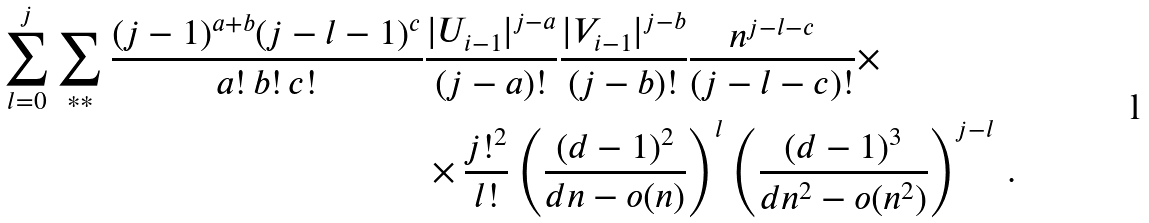<formula> <loc_0><loc_0><loc_500><loc_500>\sum _ { l = 0 } ^ { j } \sum _ { * * } \frac { ( j - 1 ) ^ { a + b } ( j - l - 1 ) ^ { c } } { a ! \, b ! \, c ! } & \frac { | U _ { i - 1 } | ^ { j - a } } { ( j - a ) ! } \frac { | V _ { i - 1 } | ^ { j - b } } { ( j - b ) ! } \frac { n ^ { j - l - c } } { ( j - l - c ) ! } \times \\ & \times \frac { j ! ^ { 2 } } { l ! } \left ( \frac { ( d - 1 ) ^ { 2 } } { d n - o ( n ) } \right ) ^ { l } \left ( \frac { ( d - 1 ) ^ { 3 } } { d n ^ { 2 } - o ( n ^ { 2 } ) } \right ) ^ { j - l } \, .</formula> 